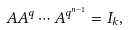Convert formula to latex. <formula><loc_0><loc_0><loc_500><loc_500>A A ^ { q } \cdots A ^ { q ^ { n - 1 } } = I _ { k } ,</formula> 